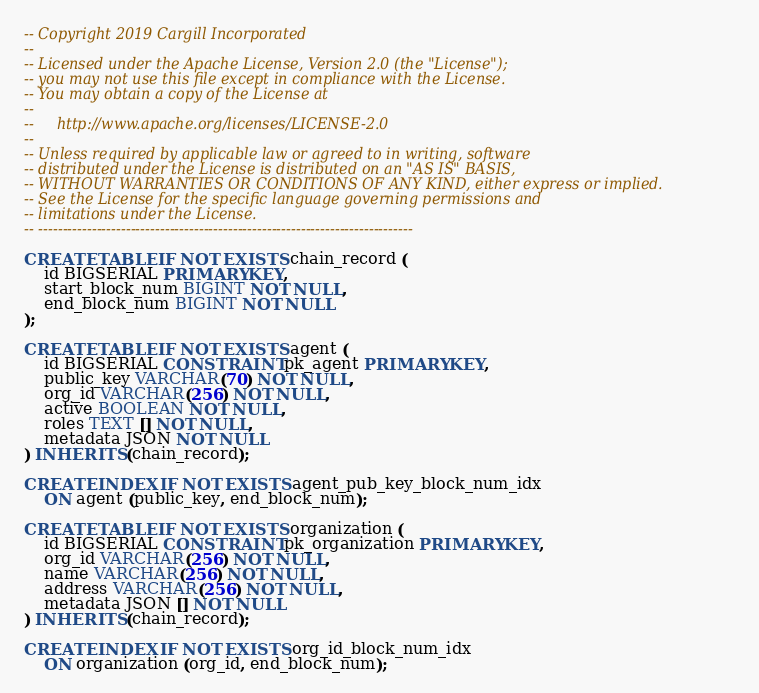Convert code to text. <code><loc_0><loc_0><loc_500><loc_500><_SQL_>-- Copyright 2019 Cargill Incorporated
--
-- Licensed under the Apache License, Version 2.0 (the "License");
-- you may not use this file except in compliance with the License.
-- You may obtain a copy of the License at
--
--     http://www.apache.org/licenses/LICENSE-2.0
--
-- Unless required by applicable law or agreed to in writing, software
-- distributed under the License is distributed on an "AS IS" BASIS,
-- WITHOUT WARRANTIES OR CONDITIONS OF ANY KIND, either express or implied.
-- See the License for the specific language governing permissions and
-- limitations under the License.
-- -----------------------------------------------------------------------------

CREATE TABLE IF NOT EXISTS chain_record (
    id BIGSERIAL PRIMARY KEY,
    start_block_num BIGINT NOT NULL,
    end_block_num BIGINT NOT NULL
);

CREATE TABLE IF NOT EXISTS agent (
    id BIGSERIAL CONSTRAINT pk_agent PRIMARY KEY,
    public_key VARCHAR(70) NOT NULL,
    org_id VARCHAR(256) NOT NULL,
    active BOOLEAN NOT NULL,
    roles TEXT [] NOT NULL,
    metadata JSON NOT NULL
) INHERITS (chain_record);

CREATE INDEX IF NOT EXISTS agent_pub_key_block_num_idx
    ON agent (public_key, end_block_num);

CREATE TABLE IF NOT EXISTS organization (
    id BIGSERIAL CONSTRAINT pk_organization PRIMARY KEY,
    org_id VARCHAR(256) NOT NULL,
    name VARCHAR(256) NOT NULL,
    address VARCHAR(256) NOT NULL,
    metadata JSON [] NOT NULL
) INHERITS (chain_record);

CREATE INDEX IF NOT EXISTS org_id_block_num_idx
    ON organization (org_id, end_block_num);
</code> 